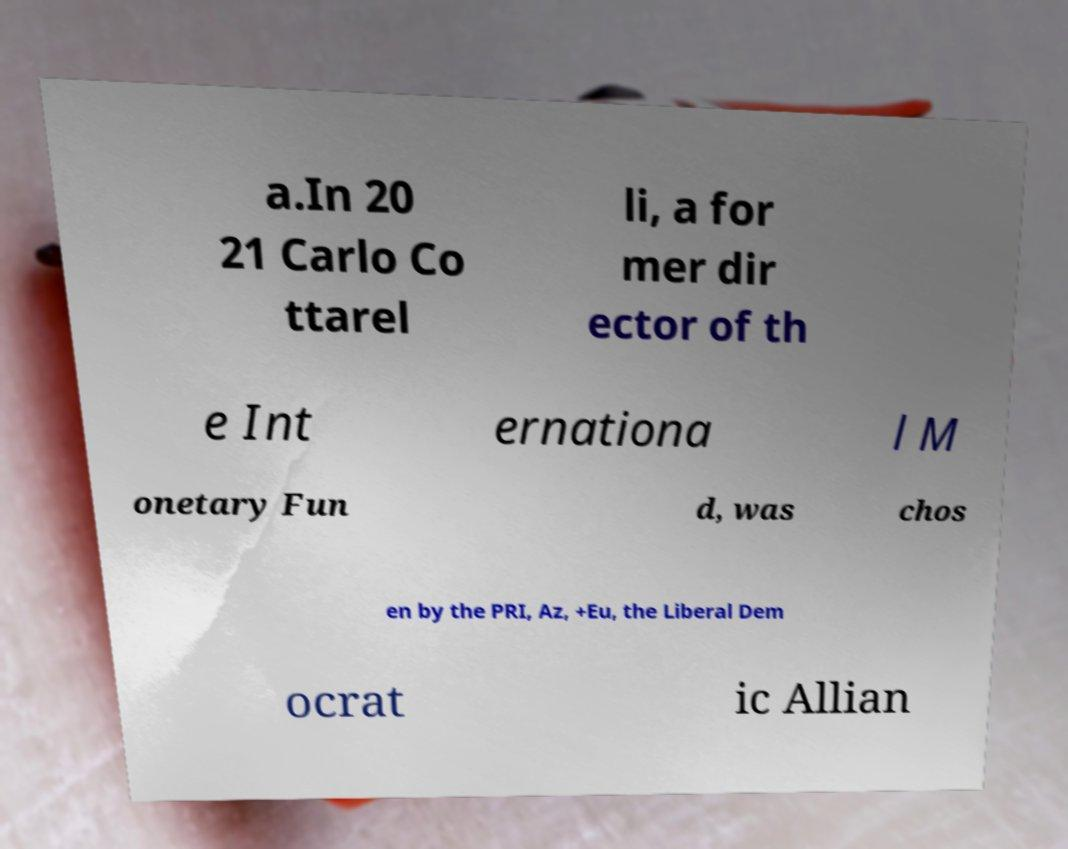I need the written content from this picture converted into text. Can you do that? a.In 20 21 Carlo Co ttarel li, a for mer dir ector of th e Int ernationa l M onetary Fun d, was chos en by the PRI, Az, +Eu, the Liberal Dem ocrat ic Allian 